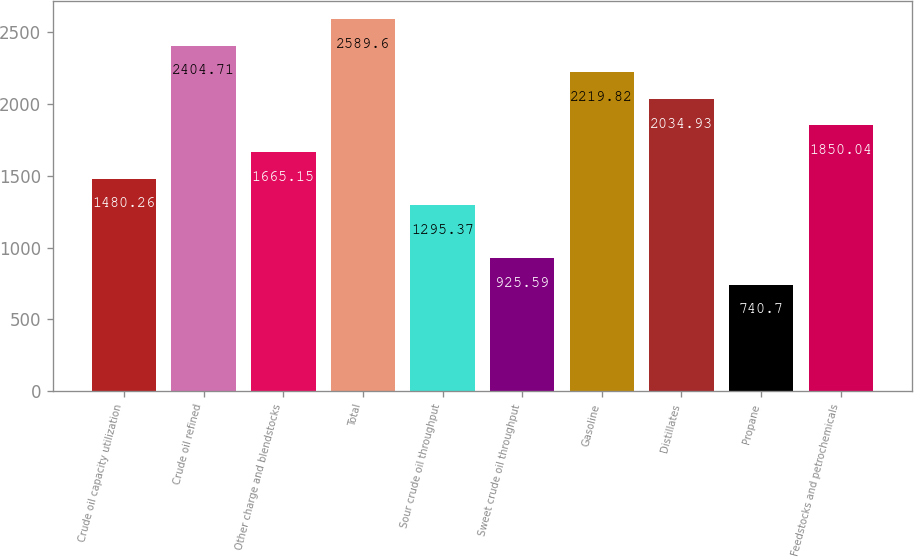<chart> <loc_0><loc_0><loc_500><loc_500><bar_chart><fcel>Crude oil capacity utilization<fcel>Crude oil refined<fcel>Other charge and blendstocks<fcel>Total<fcel>Sour crude oil throughput<fcel>Sweet crude oil throughput<fcel>Gasoline<fcel>Distillates<fcel>Propane<fcel>Feedstocks and petrochemicals<nl><fcel>1480.26<fcel>2404.71<fcel>1665.15<fcel>2589.6<fcel>1295.37<fcel>925.59<fcel>2219.82<fcel>2034.93<fcel>740.7<fcel>1850.04<nl></chart> 